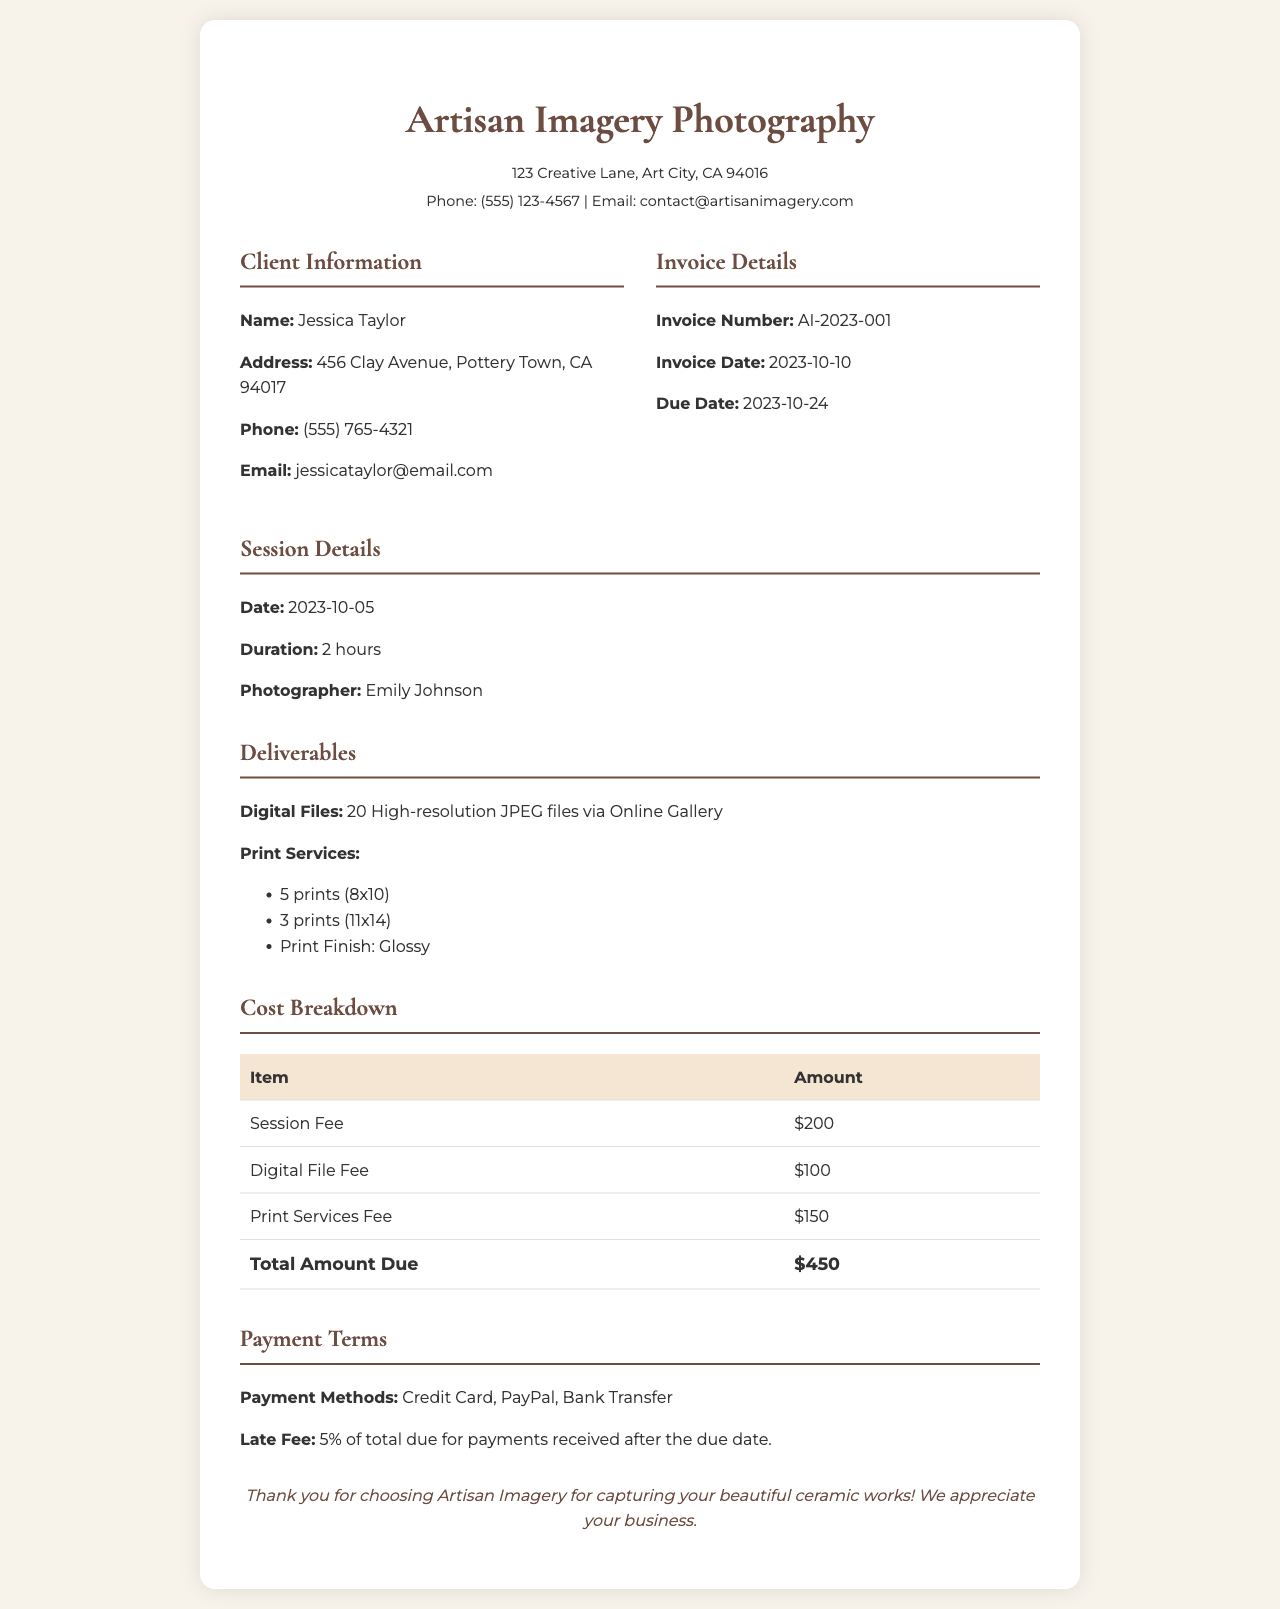what is the invoice number? The invoice number is a unique identifier for this invoice, which is located in the invoice details section.
Answer: AI-2023-001 who is the photographer? The photographer's name is mentioned in the session details section of the document.
Answer: Emily Johnson how many prints are requested? The total number of prints is found in the deliverables section, which sums the prints listed.
Answer: 8 prints what is the duration of the photography session? The duration of the photography session is specified in the session details section.
Answer: 2 hours what is the total amount due? The total amount due is calculated from the cost breakdown section and is highlighted at the bottom of the table.
Answer: $450 what is the due date for payment? The due date is specified in the invoice details section of the document.
Answer: 2023-10-24 what types of payments are accepted? The accepted payment methods are listed under the payment terms section.
Answer: Credit Card, PayPal, Bank Transfer how many digital files will be delivered? The number of digital files is stated in the deliverables section of the document.
Answer: 20 High-resolution JPEG files 